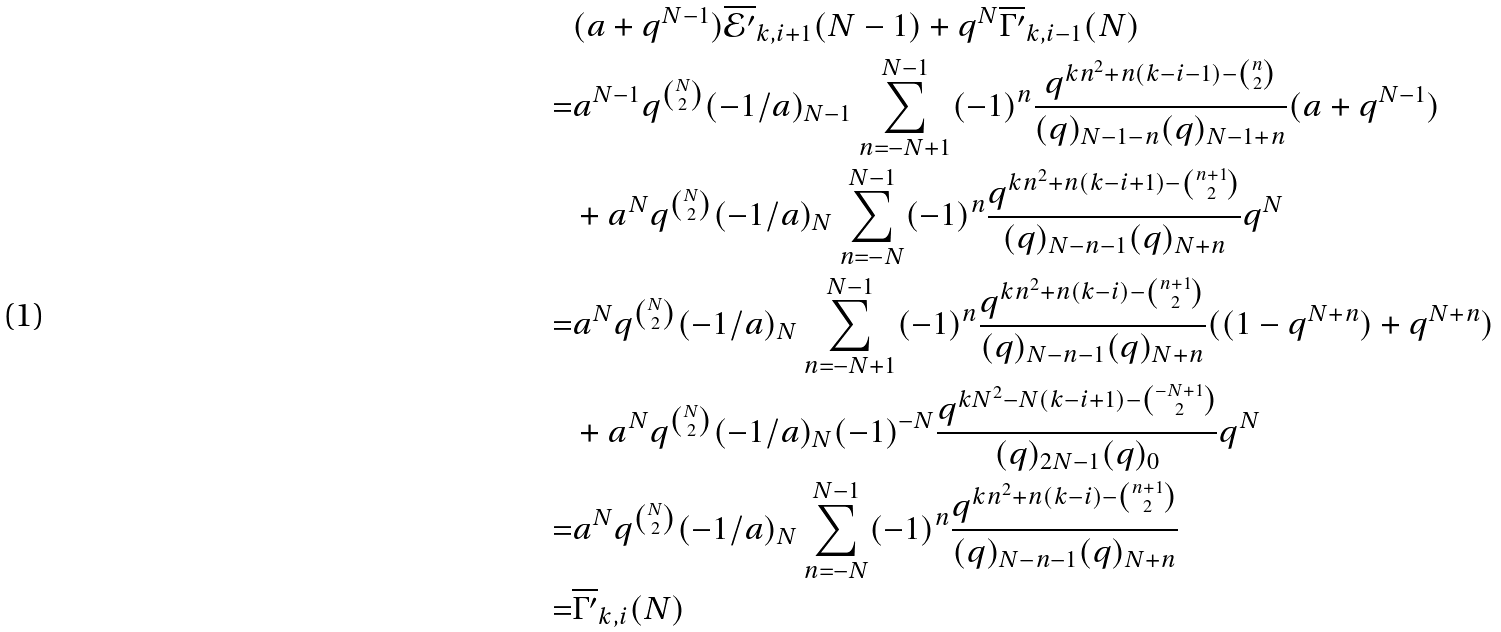Convert formula to latex. <formula><loc_0><loc_0><loc_500><loc_500>& ( a + q ^ { N - 1 } ) \overline { \mathcal { E } ^ { \prime } } _ { k , i + 1 } ( N - 1 ) + q ^ { N } \overline { \Gamma ^ { \prime } } _ { k , i - 1 } ( N ) \\ = & a ^ { N - 1 } q ^ { \binom { N } { 2 } } ( - 1 / a ) _ { N - 1 } \sum _ { n = - N + 1 } ^ { N - 1 } ( - 1 ) ^ { n } \frac { q ^ { k n ^ { 2 } + n ( k - i - 1 ) - { \binom { n } { 2 } } } } { ( q ) _ { N - 1 - n } ( q ) _ { N - 1 + n } } ( a + q ^ { N - 1 } ) \\ & + a ^ { N } q ^ { \binom { N } { 2 } } ( - 1 / a ) _ { N } \sum _ { n = - N } ^ { N - 1 } ( - 1 ) ^ { n } \frac { q ^ { k n ^ { 2 } + n ( k - i + 1 ) - { \binom { n + 1 } { 2 } } } } { ( q ) _ { N - n - 1 } ( q ) _ { N + n } } q ^ { N } \\ = & a ^ { N } q ^ { \binom { N } { 2 } } ( - 1 / a ) _ { N } \sum _ { n = - N + 1 } ^ { N - 1 } ( - 1 ) ^ { n } \frac { q ^ { k n ^ { 2 } + n ( k - i ) - { \binom { n + 1 } { 2 } } } } { ( q ) _ { N - n - 1 } ( q ) _ { N + n } } ( ( 1 - q ^ { N + n } ) + q ^ { N + n } ) \\ & + a ^ { N } q ^ { \binom { N } { 2 } } ( - 1 / a ) _ { N } ( - 1 ) ^ { - N } \frac { q ^ { k N ^ { 2 } - N ( k - i + 1 ) - { \binom { - N + 1 } { 2 } } } } { ( q ) _ { 2 N - 1 } ( q ) _ { 0 } } q ^ { N } \\ = & a ^ { N } q ^ { \binom { N } { 2 } } ( - 1 / a ) _ { N } \sum _ { n = - N } ^ { N - 1 } ( - 1 ) ^ { n } \frac { q ^ { k n ^ { 2 } + n ( k - i ) - { \binom { n + 1 } { 2 } } } } { ( q ) _ { N - n - 1 } ( q ) _ { N + n } } \\ = & \overline { \Gamma ^ { \prime } } _ { k , i } ( N )</formula> 